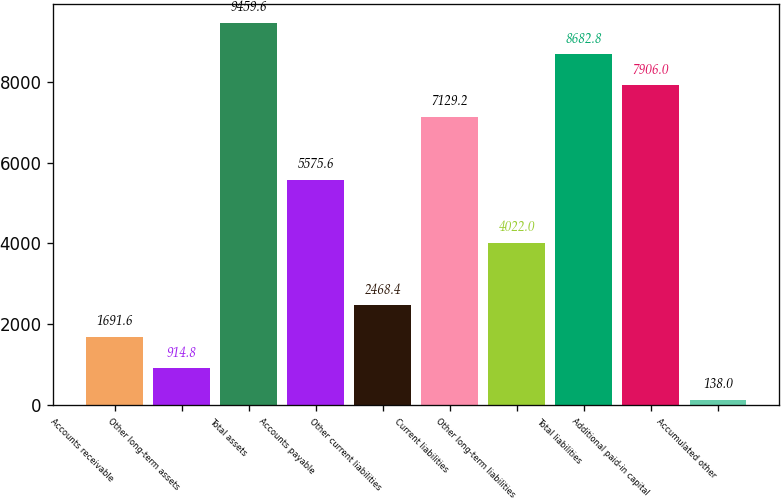Convert chart to OTSL. <chart><loc_0><loc_0><loc_500><loc_500><bar_chart><fcel>Accounts receivable<fcel>Other long-term assets<fcel>Total assets<fcel>Accounts payable<fcel>Other current liabilities<fcel>Current liabilities<fcel>Other long-term liabilities<fcel>Total liabilities<fcel>Additional paid-in capital<fcel>Accumulated other<nl><fcel>1691.6<fcel>914.8<fcel>9459.6<fcel>5575.6<fcel>2468.4<fcel>7129.2<fcel>4022<fcel>8682.8<fcel>7906<fcel>138<nl></chart> 